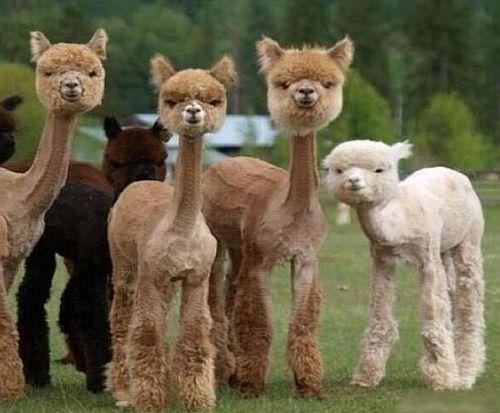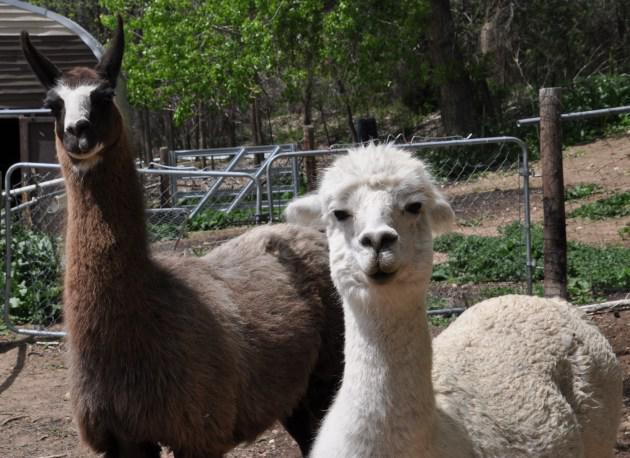The first image is the image on the left, the second image is the image on the right. For the images shown, is this caption "The left image contains at least three llamas standing in a row and gazing in the same direction." true? Answer yes or no. Yes. The first image is the image on the left, the second image is the image on the right. For the images shown, is this caption "There are two llamas in one of the images." true? Answer yes or no. Yes. 